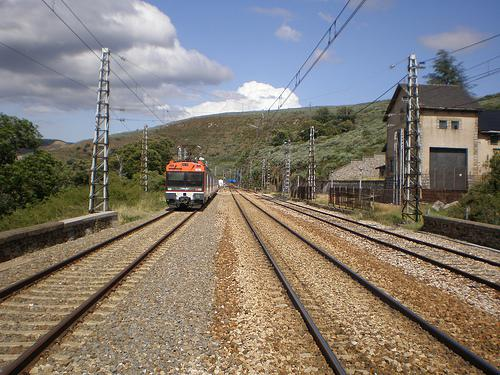Question: where does this picture take place?
Choices:
A. A concert.
B. In the Country.
C. A wedding.
D. A baptism.
Answer with the letter. Answer: B Question: how many tracks are there?
Choices:
A. 7.
B. 6.
C. 3.
D. 5.
Answer with the letter. Answer: C Question: what type of day is it?
Choices:
A. Muggy.
B. Rainy.
C. Cloudy.
D. Sunny.
Answer with the letter. Answer: C Question: who will be driving the train?
Choices:
A. A man.
B. Engineer.
C. A woman.
D. A felon.
Answer with the letter. Answer: B 